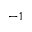<formula> <loc_0><loc_0><loc_500><loc_500>^ { - 1 }</formula> 